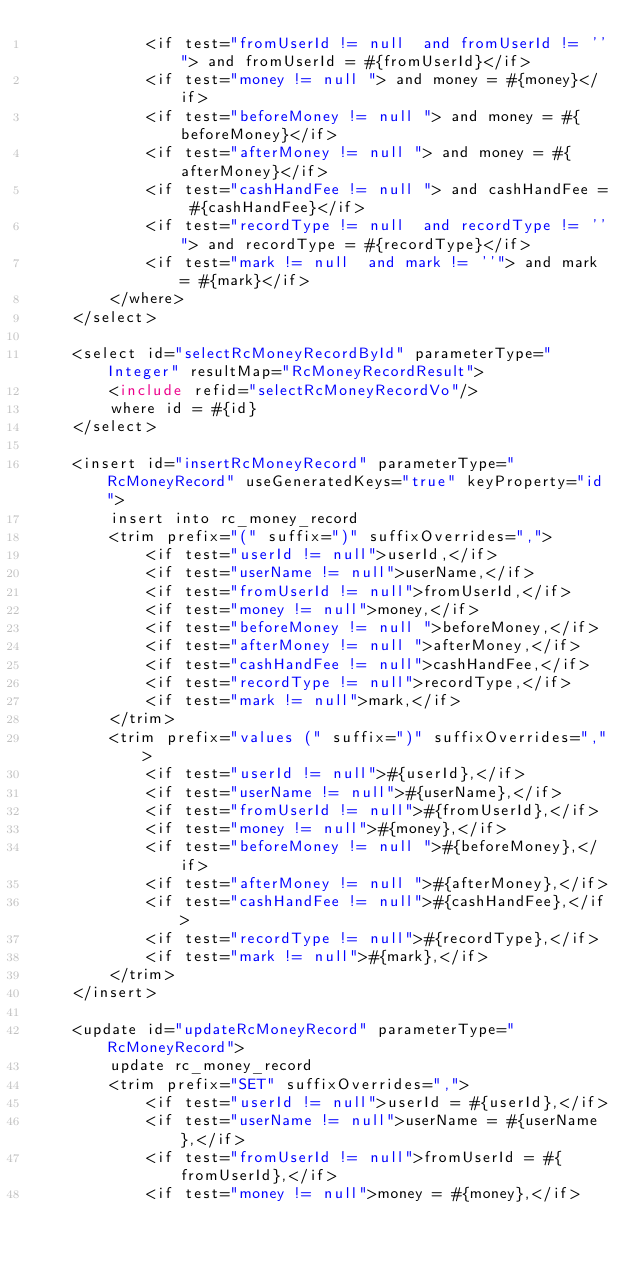<code> <loc_0><loc_0><loc_500><loc_500><_XML_>            <if test="fromUserId != null  and fromUserId != ''"> and fromUserId = #{fromUserId}</if>
            <if test="money != null "> and money = #{money}</if>
            <if test="beforeMoney != null "> and money = #{beforeMoney}</if>
            <if test="afterMoney != null "> and money = #{afterMoney}</if>
            <if test="cashHandFee != null "> and cashHandFee = #{cashHandFee}</if>
            <if test="recordType != null  and recordType != ''"> and recordType = #{recordType}</if>
            <if test="mark != null  and mark != ''"> and mark = #{mark}</if>
        </where>
    </select>

    <select id="selectRcMoneyRecordById" parameterType="Integer" resultMap="RcMoneyRecordResult">
        <include refid="selectRcMoneyRecordVo"/>
        where id = #{id}
    </select>

    <insert id="insertRcMoneyRecord" parameterType="RcMoneyRecord" useGeneratedKeys="true" keyProperty="id">
        insert into rc_money_record
        <trim prefix="(" suffix=")" suffixOverrides=",">
            <if test="userId != null">userId,</if>
            <if test="userName != null">userName,</if>
            <if test="fromUserId != null">fromUserId,</if>
            <if test="money != null">money,</if>
            <if test="beforeMoney != null ">beforeMoney,</if>
            <if test="afterMoney != null ">afterMoney,</if>
            <if test="cashHandFee != null">cashHandFee,</if>
            <if test="recordType != null">recordType,</if>
            <if test="mark != null">mark,</if>
        </trim>
        <trim prefix="values (" suffix=")" suffixOverrides=",">
            <if test="userId != null">#{userId},</if>
            <if test="userName != null">#{userName},</if>
            <if test="fromUserId != null">#{fromUserId},</if>
            <if test="money != null">#{money},</if>
            <if test="beforeMoney != null ">#{beforeMoney},</if>
            <if test="afterMoney != null ">#{afterMoney},</if>
            <if test="cashHandFee != null">#{cashHandFee},</if>
            <if test="recordType != null">#{recordType},</if>
            <if test="mark != null">#{mark},</if>
        </trim>
    </insert>

    <update id="updateRcMoneyRecord" parameterType="RcMoneyRecord">
        update rc_money_record
        <trim prefix="SET" suffixOverrides=",">
            <if test="userId != null">userId = #{userId},</if>
            <if test="userName != null">userName = #{userName},</if>
            <if test="fromUserId != null">fromUserId = #{fromUserId},</if>
            <if test="money != null">money = #{money},</if></code> 